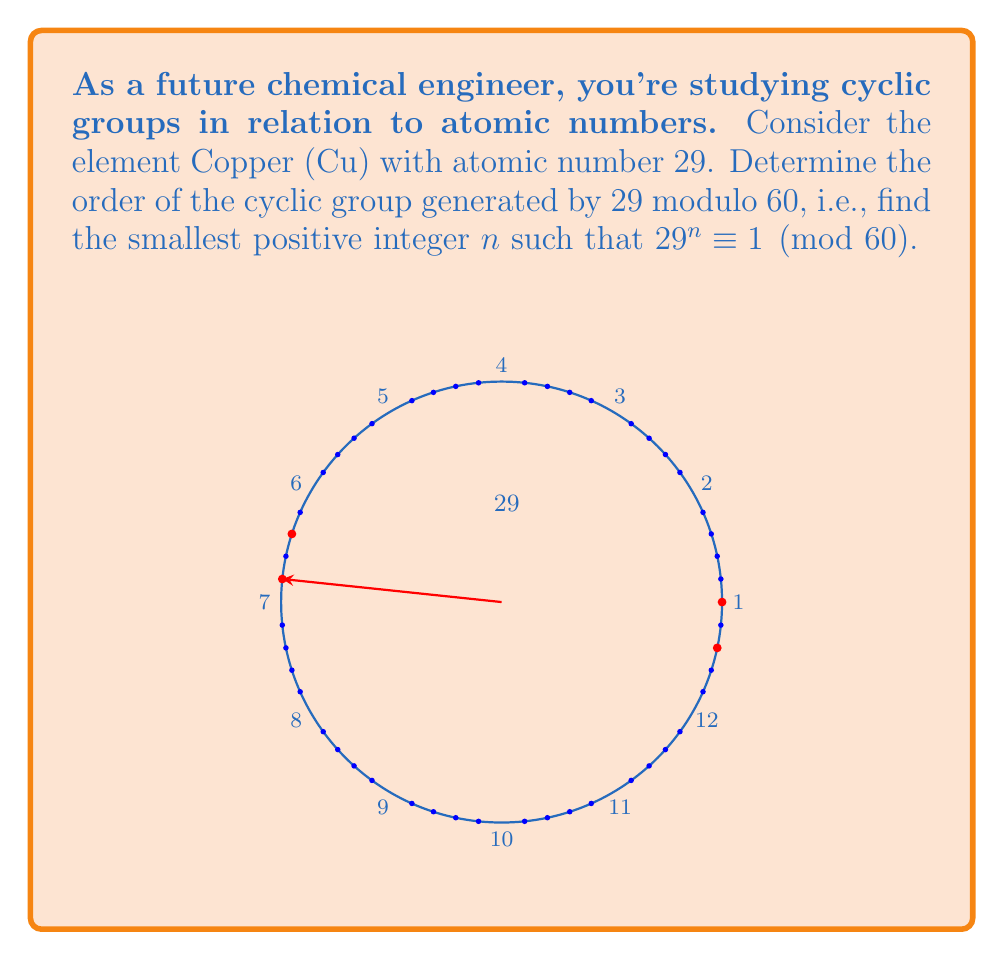Can you solve this math problem? Let's approach this step-by-step:

1) First, we need to understand what the question is asking. We're looking for the smallest positive integer $n$ such that $29^n \equiv 1 \pmod{60}$.

2) This is equivalent to finding the smallest $n$ where 60 divides $29^n - 1$.

3) We can start by computing powers of 29 modulo 60:

   $29^1 \equiv 29 \pmod{60}$
   $29^2 \equiv 29 \cdot 29 \equiv 841 \equiv 1 \pmod{60}$

4) We've found that $29^2 \equiv 1 \pmod{60}$, so the order of the cyclic group is 2.

5) To verify, let's check that there's no smaller positive integer that works:
   $29^1 \equiv 29 \not\equiv 1 \pmod{60}$

6) Therefore, 2 is indeed the smallest positive integer $n$ such that $29^n \equiv 1 \pmod{60}$.

7) In group theory terms, this means that the element 29 generates a cyclic subgroup of order 2 in the multiplicative group of integers modulo 60.

8) Visually, in the diagram, we can see that starting from 0 and repeatedly adding 29 (modulo 60) brings us back to 0 after just two steps, confirming our calculation.
Answer: 2 